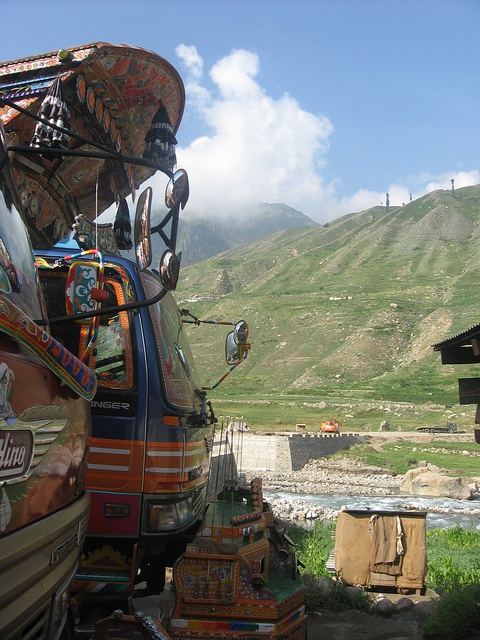Describe the objects in this image and their specific colors. I can see bus in darkgray, black, maroon, and gray tones, bus in darkgray, black, gray, and maroon tones, and bus in darkgray, gray, tan, and lightpink tones in this image. 